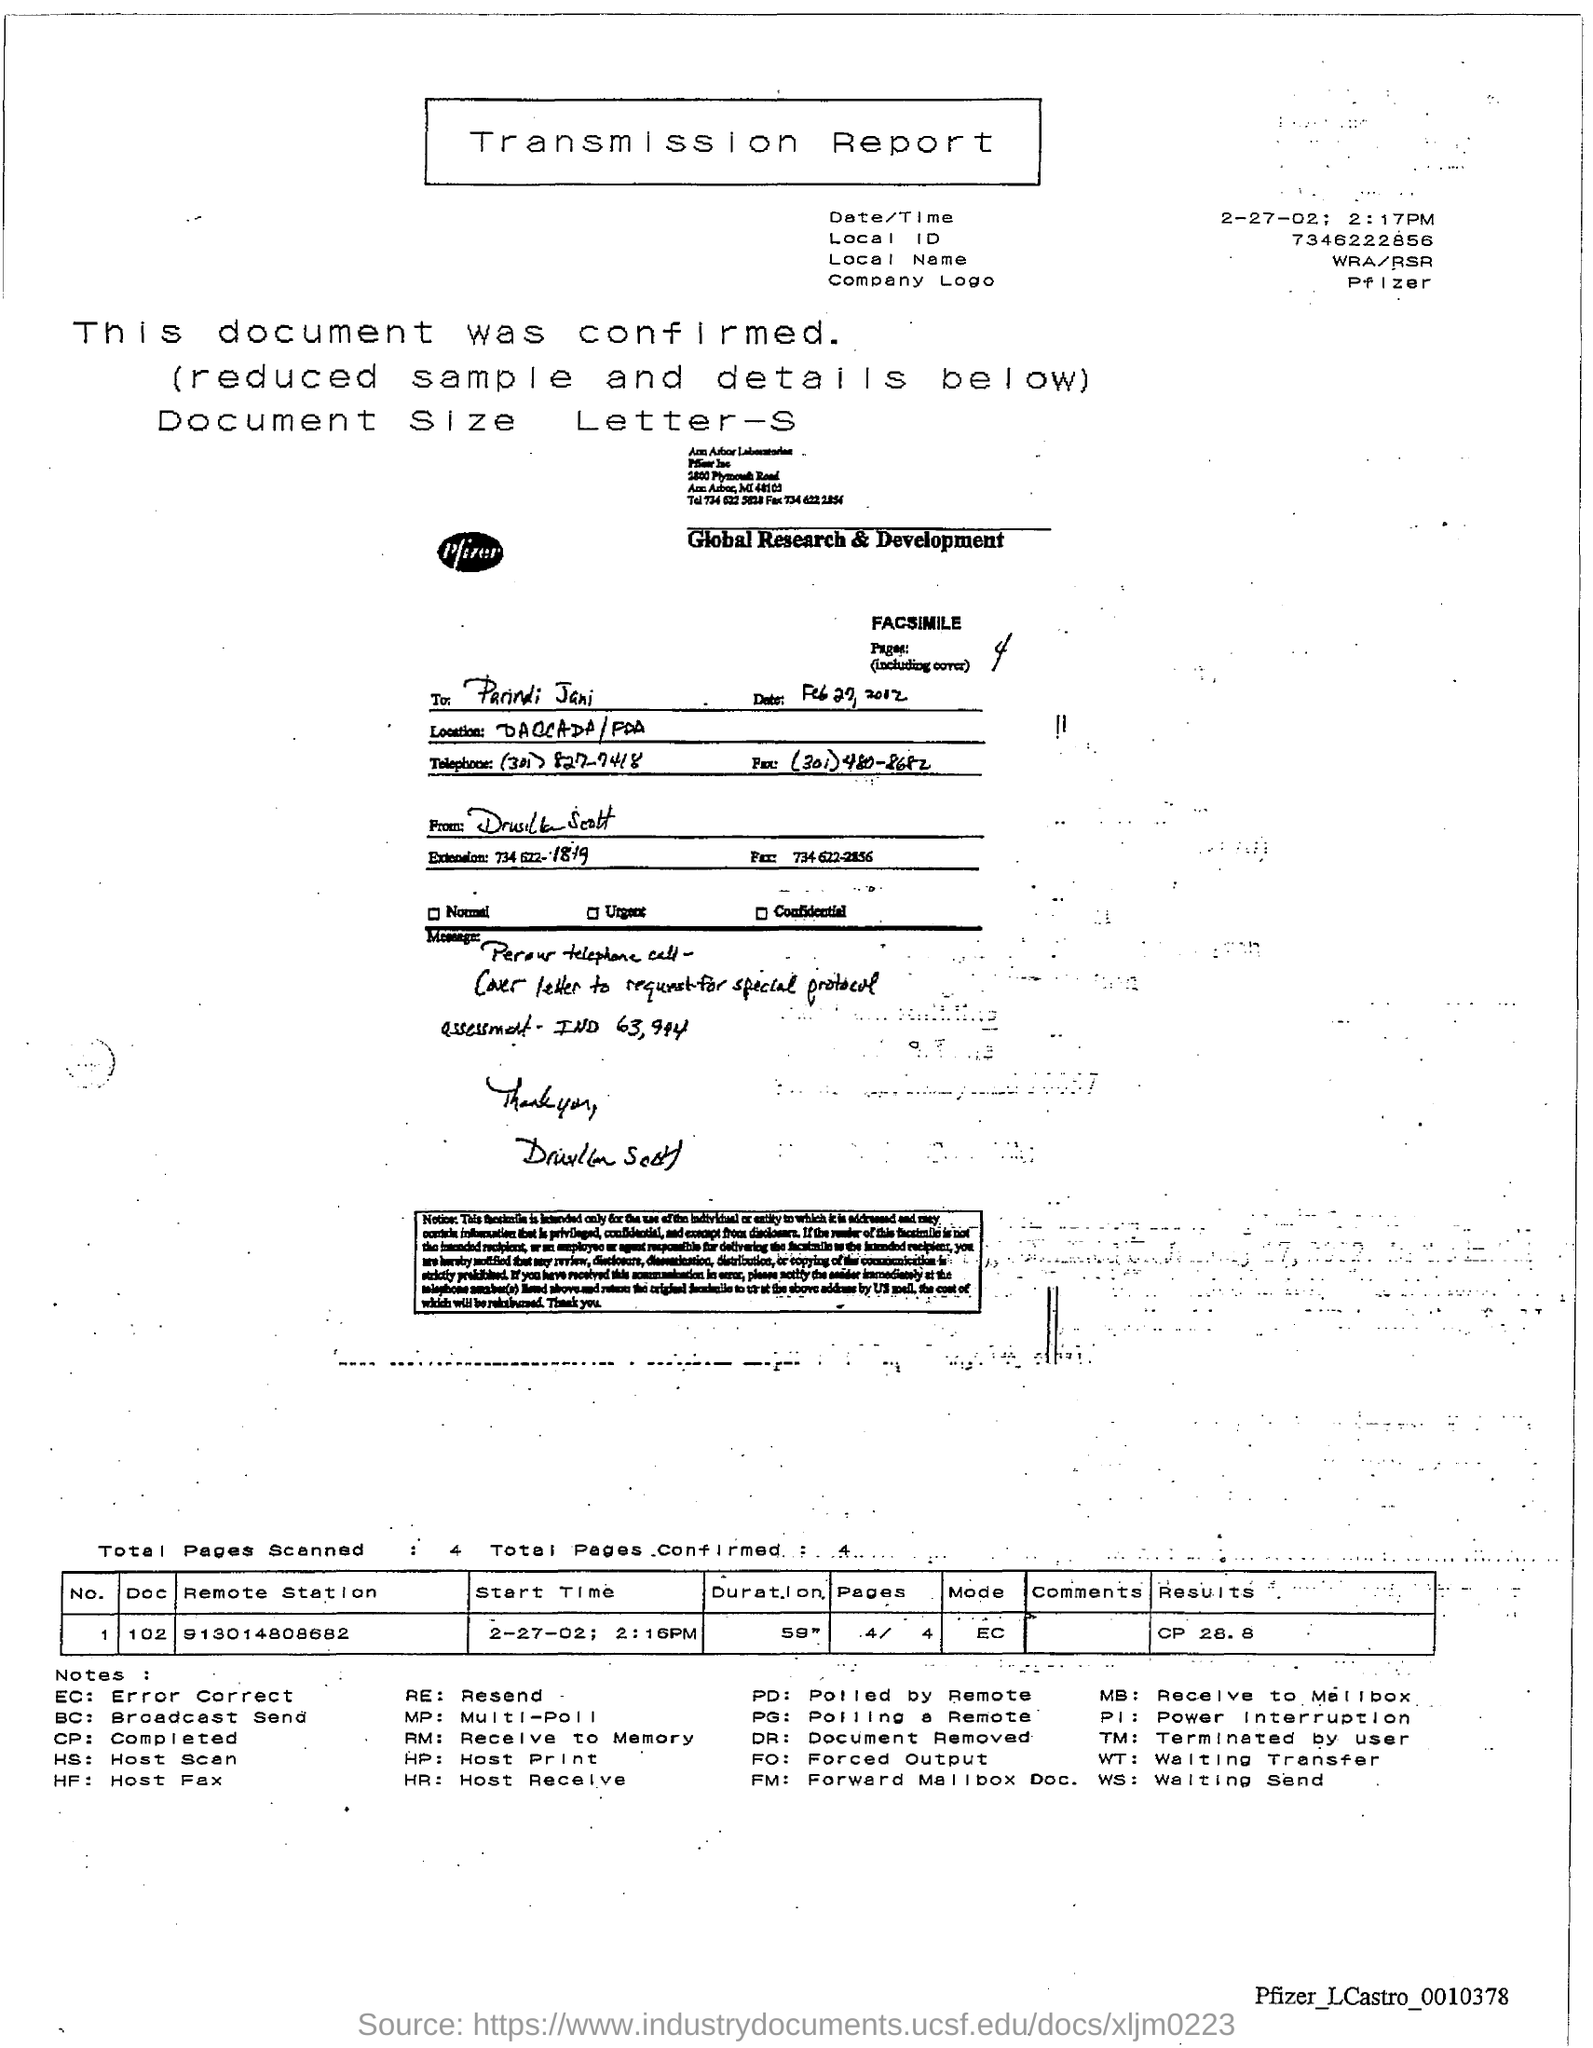Outline some significant characteristics in this image. The document is titled 'TRANSMISSION REPORT.' What is the local ID number? 7346222856... The date and time mentioned is February 27, 2002, at 2:17 PM. The specific number mentioned at the remote station is 913014808682. 